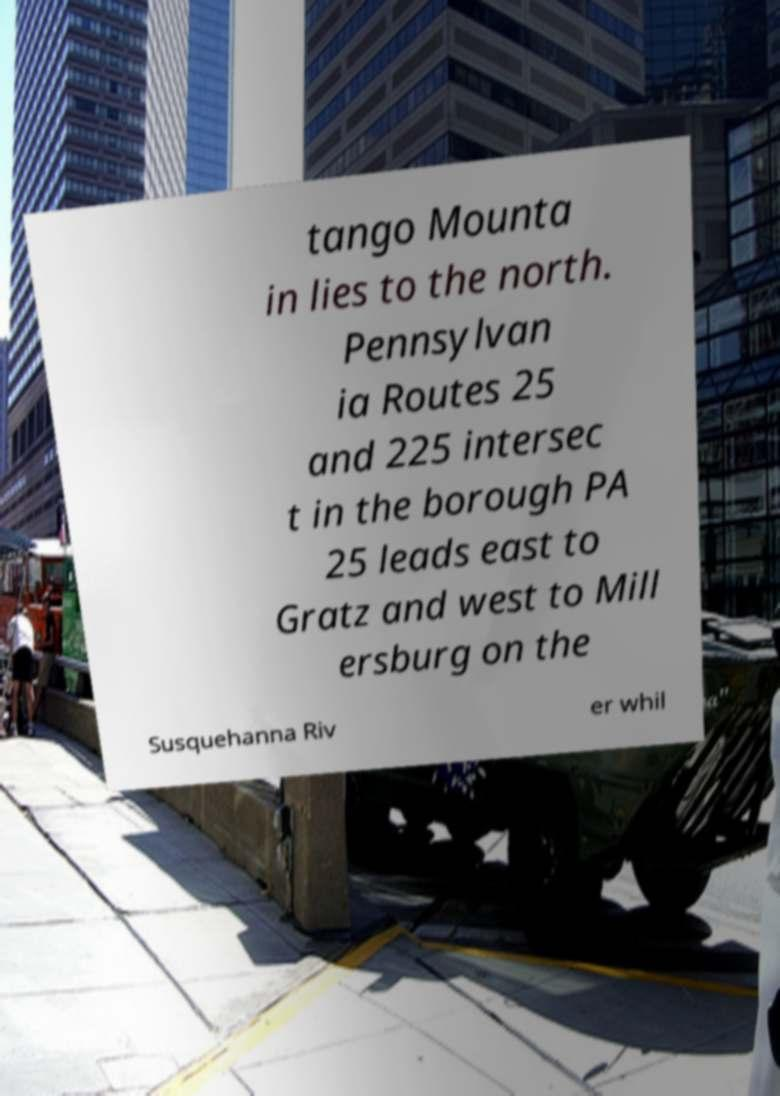Can you read and provide the text displayed in the image?This photo seems to have some interesting text. Can you extract and type it out for me? tango Mounta in lies to the north. Pennsylvan ia Routes 25 and 225 intersec t in the borough PA 25 leads east to Gratz and west to Mill ersburg on the Susquehanna Riv er whil 